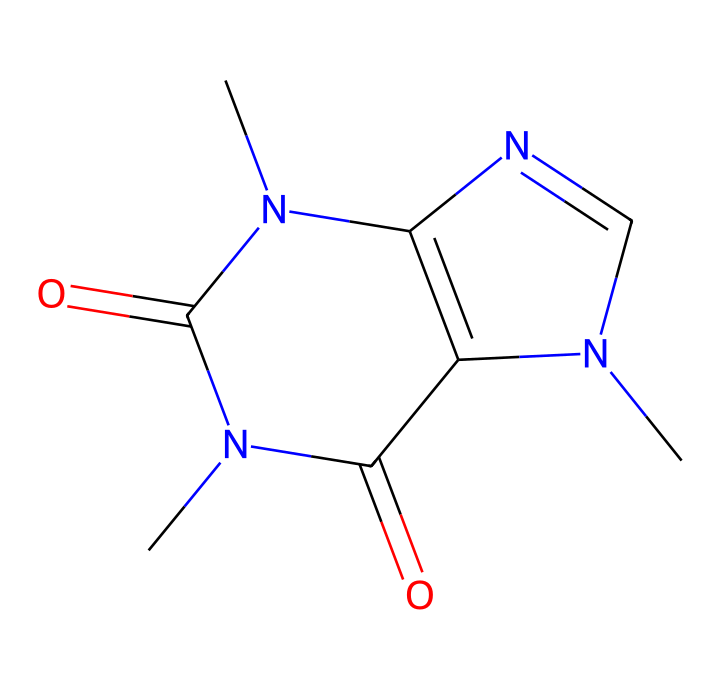What is the molecular formula of caffeine? To determine the molecular formula, we need to count the number of carbon (C), hydrogen (H), nitrogen (N), and oxygen (O) atoms in the structure represented by the SMILES. The count shows there are 8 carbons, 10 hydrogens, 4 nitrogens, and 2 oxygens, leading to the formula C8H10N4O2.
Answer: C8H10N4O2 How many nitrogen atoms are in caffeine? By examining the structure represented by the SMILES, we can identify that nitrogen atoms are marked with 'N'. Counting these provides a total of 4 nitrogen atoms.
Answer: 4 What type of compound is caffeine? The presence of multiple nitrogen atoms and its structure indicates that caffeine is classified as an alkaloid, a type of organic compound primarily found in plants.
Answer: alkaloid Which element in caffeine contributes to its stimulating effect? The nitrogen atoms, characteristic of alkaloids, are responsible for the stimulating properties of caffeine as they interact with neurotransmitters in the brain.
Answer: nitrogen What functional groups are present in caffeine? By analyzing the structure, we can identify the presence of amide and imine groups, which are recognizable by the carbonyl (C=O) and nitrogen connections.
Answer: amide and imine What is the number of rings in the caffeine structure? Observing the cyclic structure from the SMILES, we find 2 rings formed by the interconnected atoms. Counting these yields a total of 2 rings in the caffeine structure.
Answer: 2 